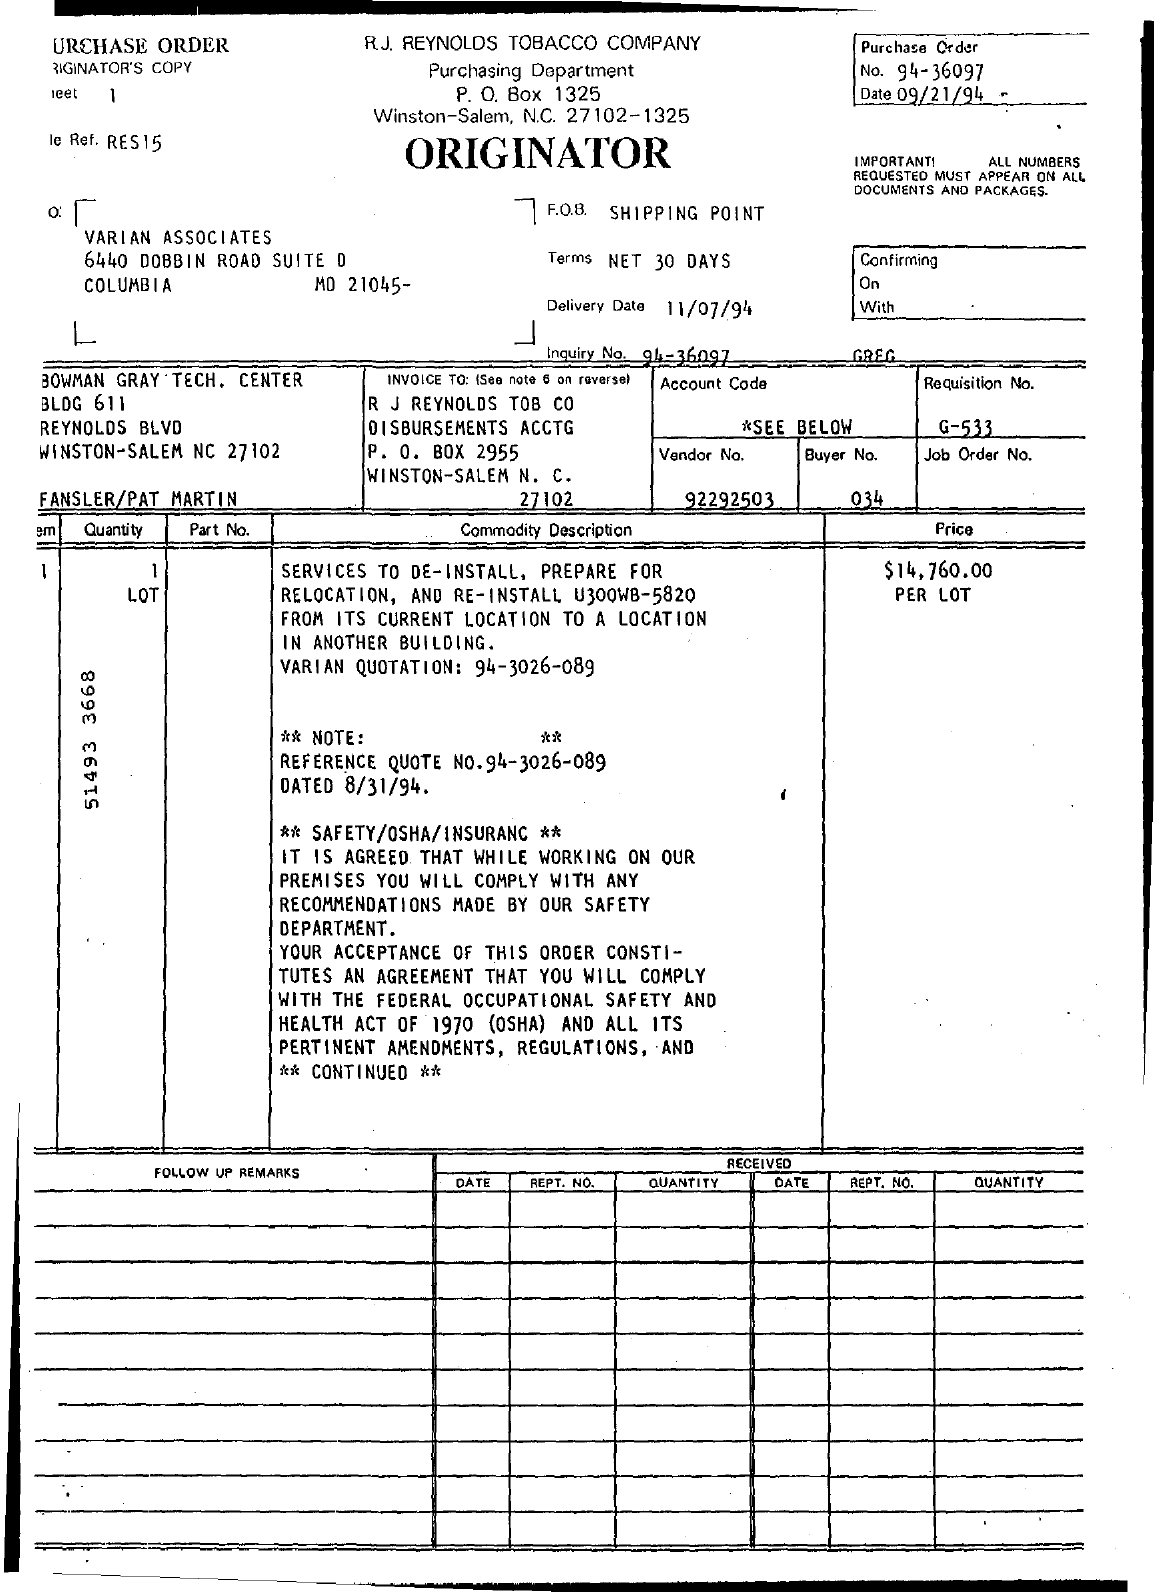What is the Purchase order number ?
Give a very brief answer. 94-36097. What is the date mentioned in the top of the document ?
Make the answer very short. 09/21/94. What is the P.O Box Number of top of the document ?
Your response must be concise. 1325. What is the Delivery Date ?
Provide a succinct answer. 11/07/94. What is the Vendor Number ?
Provide a succinct answer. 92292503. What is written in the F.O.B. Field ?
Offer a very short reply. Shipping Point. What is the Buyer Number ?
Make the answer very short. 034. 